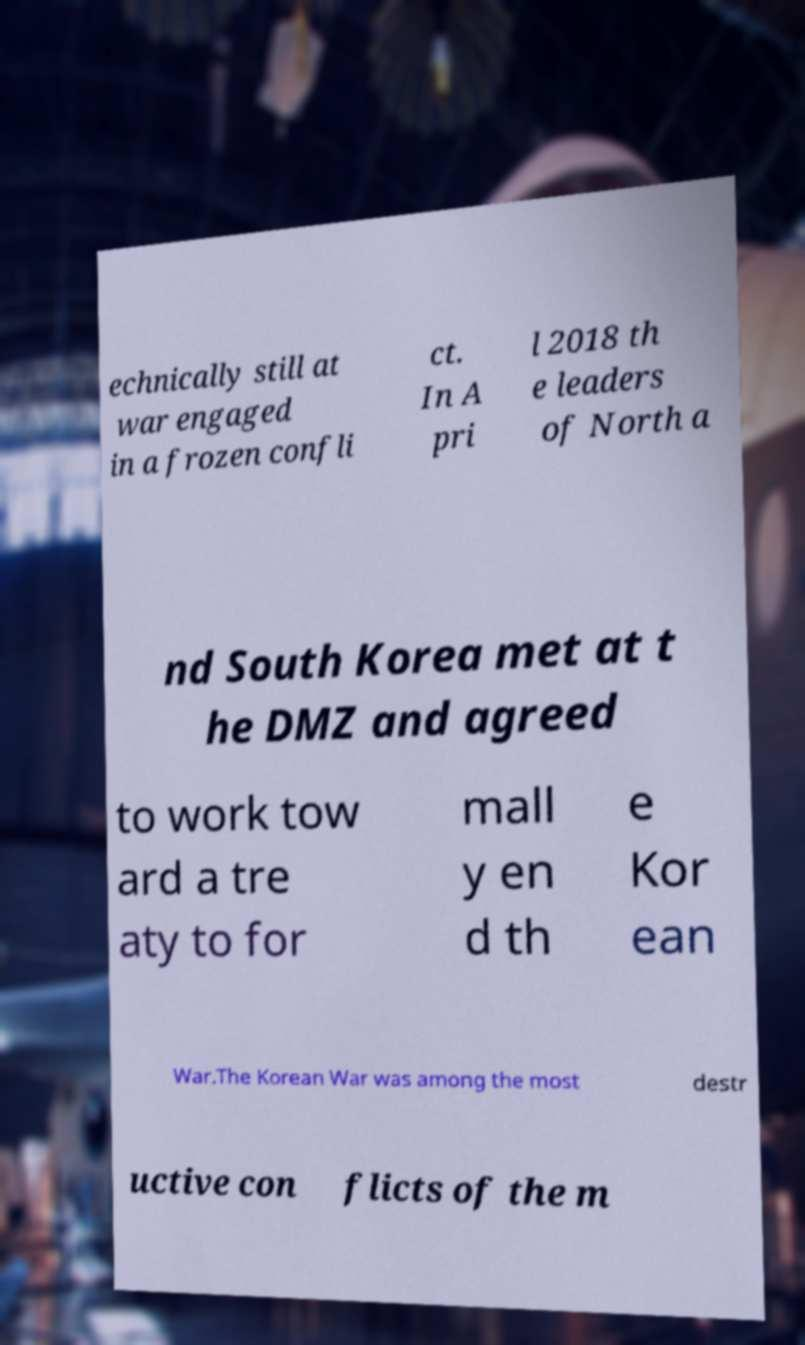Please read and relay the text visible in this image. What does it say? echnically still at war engaged in a frozen confli ct. In A pri l 2018 th e leaders of North a nd South Korea met at t he DMZ and agreed to work tow ard a tre aty to for mall y en d th e Kor ean War.The Korean War was among the most destr uctive con flicts of the m 